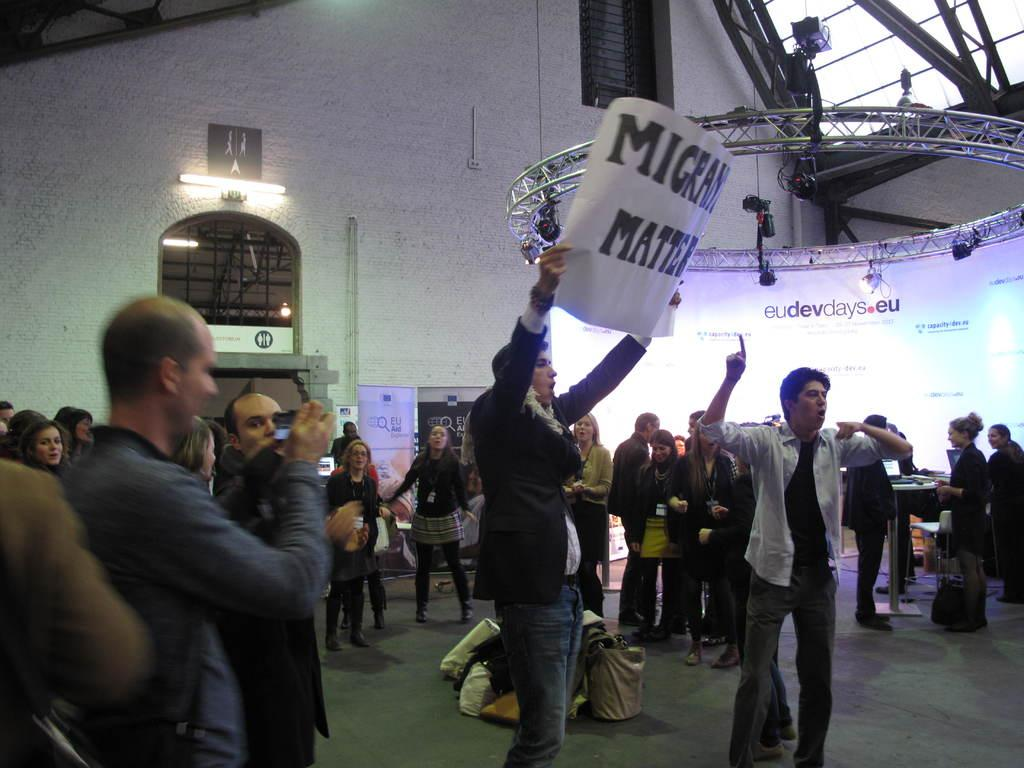Who or what can be seen in the image? There are people in the image. What is the purpose of the screen in the image? The purpose of the screen is not specified, but it is present in the image. What type of decorations are in the image? There are banners in the image. What is the color of the wall in the image? The wall in the image is white. What architectural feature is present in the image? There is a window in the image. Can you see an owl looking through the window in the image? There is no owl present in the image, nor is there any indication of an owl looking through the window. 